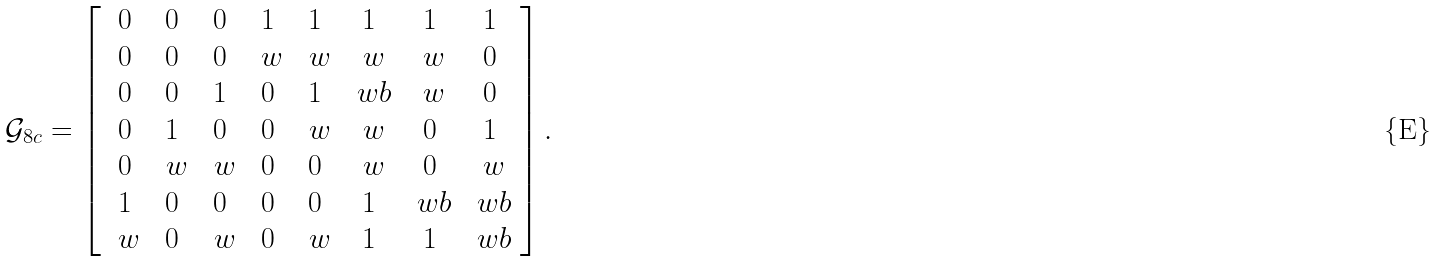Convert formula to latex. <formula><loc_0><loc_0><loc_500><loc_500>\mathcal { G } _ { 8 c } = \left [ \begin{array} { c c c c c c c c } 0 & 0 & 0 & 1 & 1 & 1 & 1 & 1 \\ 0 & 0 & 0 & \ w & \ w & \ w & \ w & 0 \\ 0 & 0 & 1 & 0 & 1 & \ w b & \ w & 0 \\ 0 & 1 & 0 & 0 & \ w & \ w & 0 & 1 \\ 0 & \ w & \ w & 0 & 0 & \ w & 0 & \ w \\ 1 & 0 & 0 & 0 & 0 & 1 & \ w b & \ w b \\ \ w & 0 & \ w & 0 & \ w & 1 & 1 & \ w b \end{array} \right ] .</formula> 